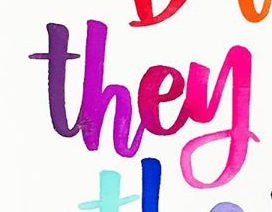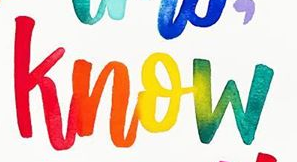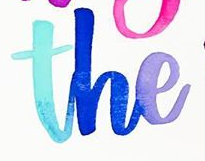Transcribe the words shown in these images in order, separated by a semicolon. they; know; the 